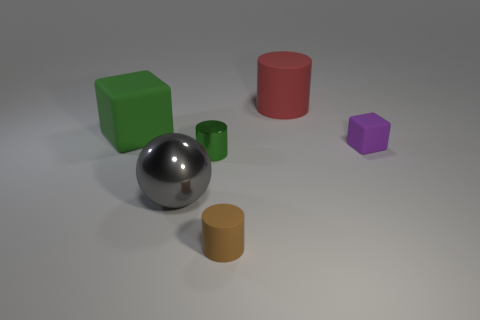There is a big object that is to the right of the large green cube and in front of the red thing; what is its material? The large object to the right of the green cube and in front of the red cylinder appears to be made of a shiny, reflective metal, likely steel or aluminum, as indicated by its silvery color and the reflections visible on its surface. 